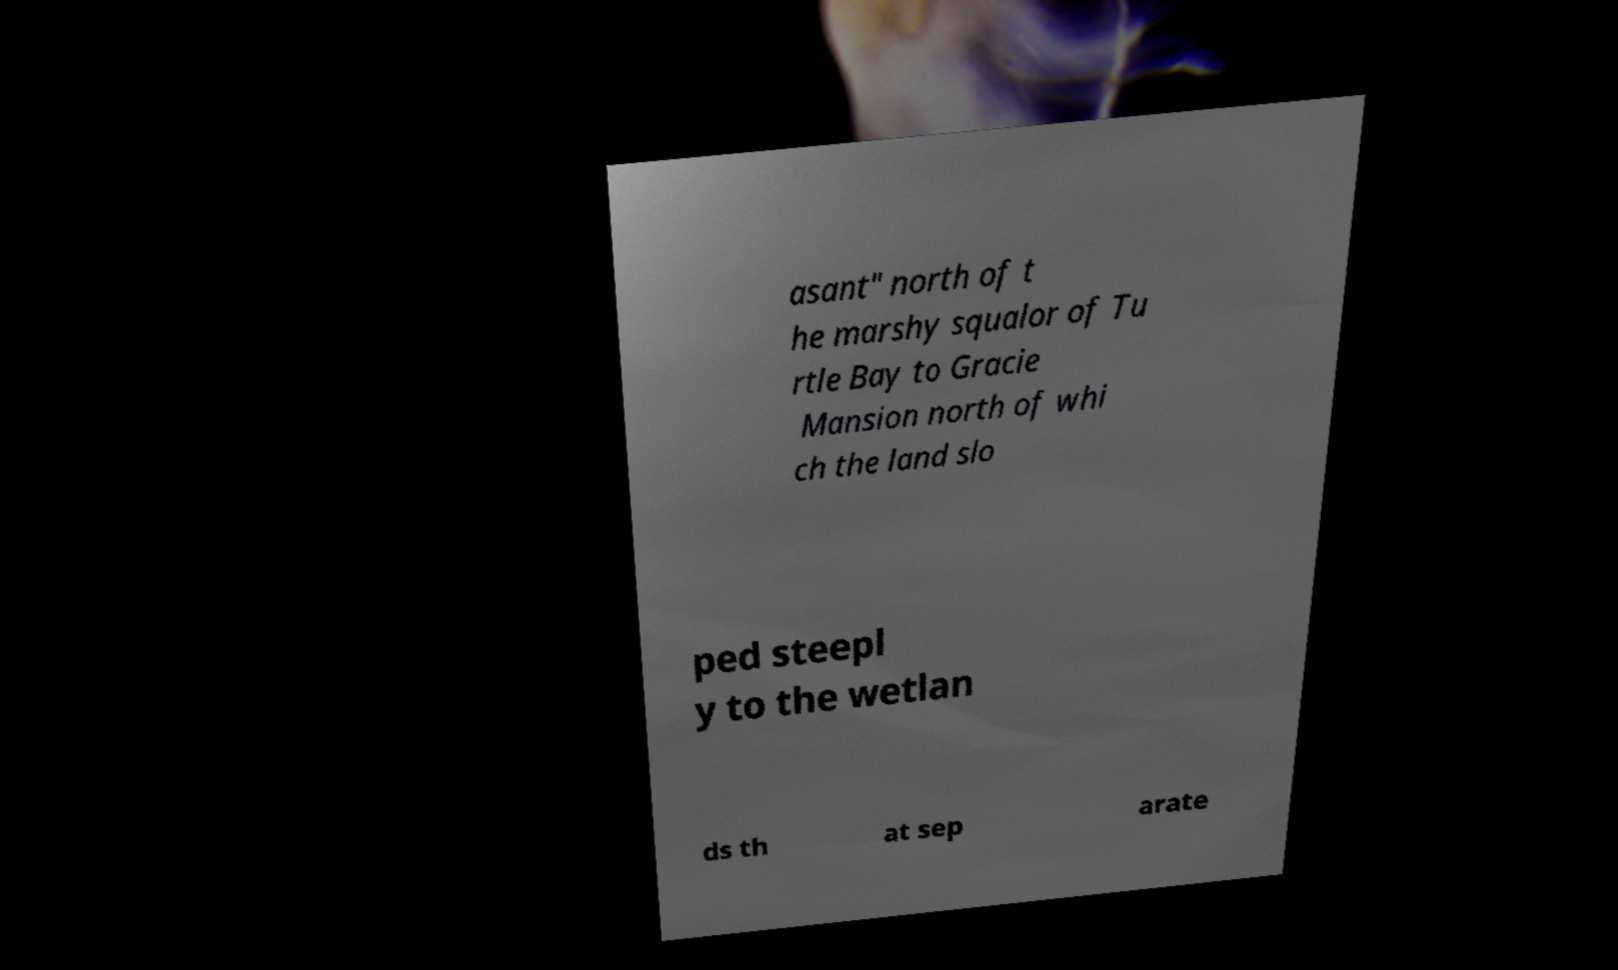Please read and relay the text visible in this image. What does it say? asant" north of t he marshy squalor of Tu rtle Bay to Gracie Mansion north of whi ch the land slo ped steepl y to the wetlan ds th at sep arate 